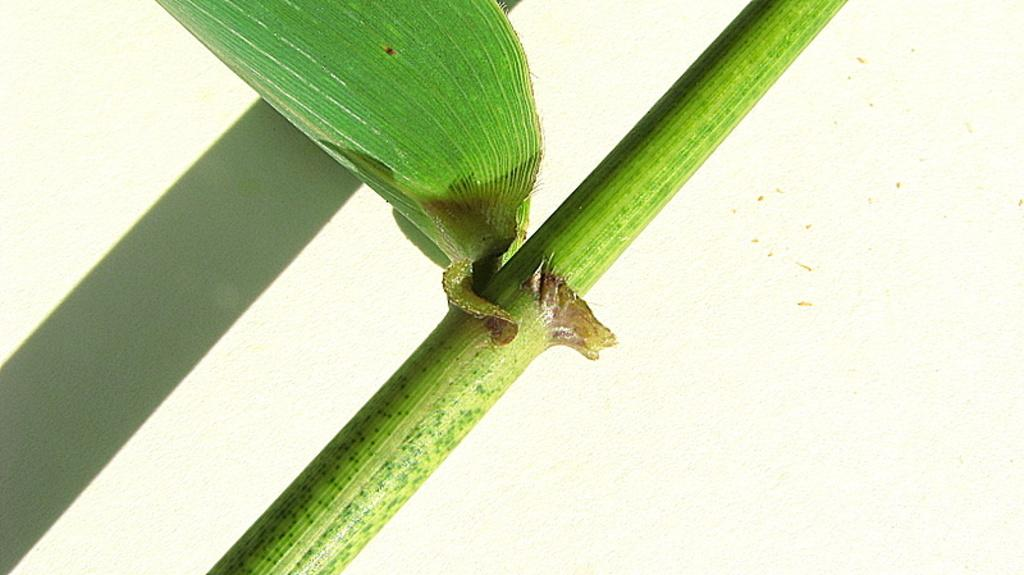What is present in the image related to vegetation? There is a plant in the image. Can you describe any specific part of the plant? There is a leaf on the plant. What else can be observed in the image related to the plant? There is a shadow of a plant on the wall in the image. How many cherries are hanging from the plant in the image? There are no cherries present in the image; it only features a plant and a leaf. Is there a nest visible in the image? There is no nest present in the image. 